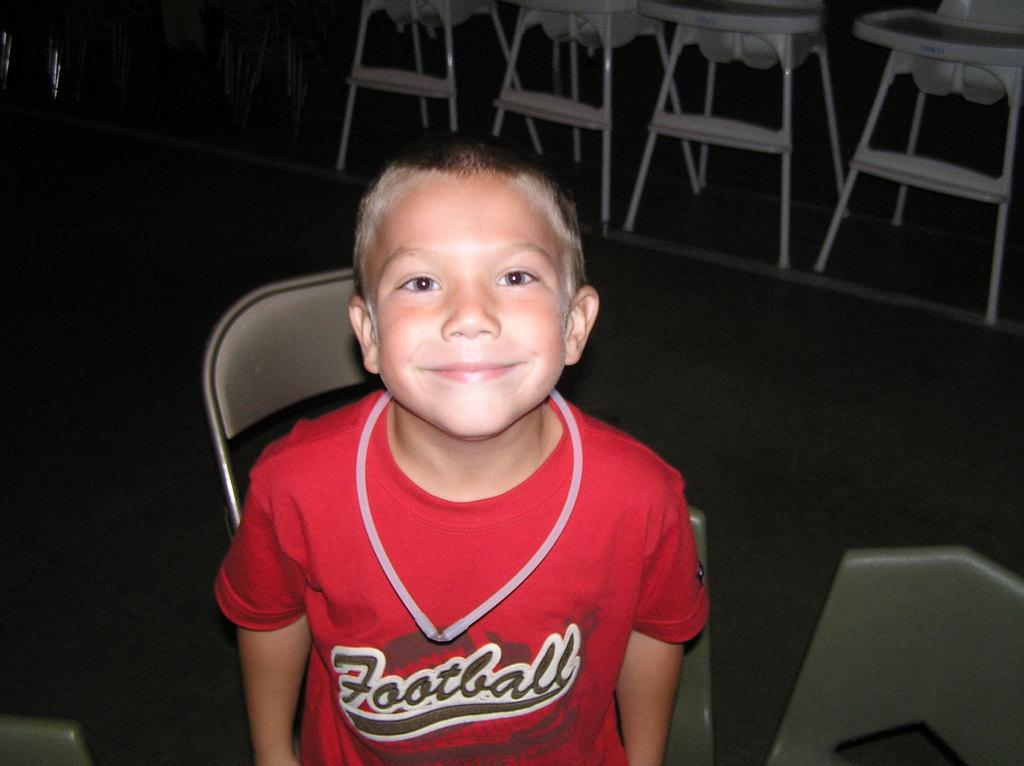<image>
Share a concise interpretation of the image provided. A young boy is wearing a red shirt that says football on the front. 